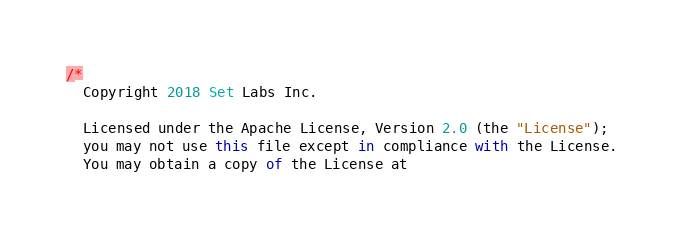Convert code to text. <code><loc_0><loc_0><loc_500><loc_500><_TypeScript_>/*
  Copyright 2018 Set Labs Inc.

  Licensed under the Apache License, Version 2.0 (the "License");
  you may not use this file except in compliance with the License.
  You may obtain a copy of the License at
</code> 